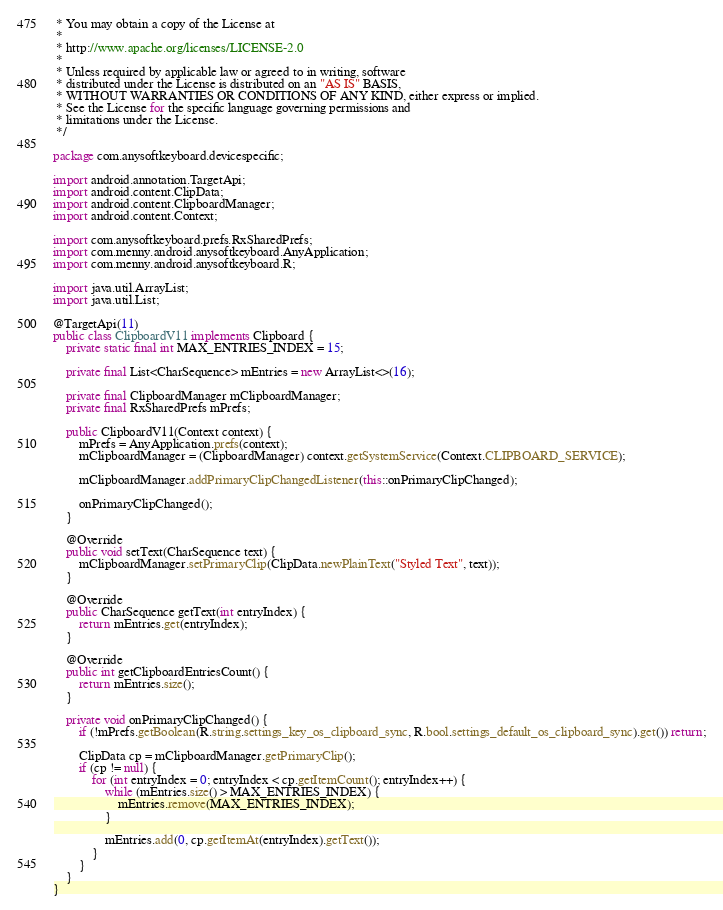Convert code to text. <code><loc_0><loc_0><loc_500><loc_500><_Java_> * You may obtain a copy of the License at
 *
 * http://www.apache.org/licenses/LICENSE-2.0
 *
 * Unless required by applicable law or agreed to in writing, software
 * distributed under the License is distributed on an "AS IS" BASIS,
 * WITHOUT WARRANTIES OR CONDITIONS OF ANY KIND, either express or implied.
 * See the License for the specific language governing permissions and
 * limitations under the License.
 */

package com.anysoftkeyboard.devicespecific;

import android.annotation.TargetApi;
import android.content.ClipData;
import android.content.ClipboardManager;
import android.content.Context;

import com.anysoftkeyboard.prefs.RxSharedPrefs;
import com.menny.android.anysoftkeyboard.AnyApplication;
import com.menny.android.anysoftkeyboard.R;

import java.util.ArrayList;
import java.util.List;

@TargetApi(11)
public class ClipboardV11 implements Clipboard {
    private static final int MAX_ENTRIES_INDEX = 15;

    private final List<CharSequence> mEntries = new ArrayList<>(16);

    private final ClipboardManager mClipboardManager;
    private final RxSharedPrefs mPrefs;

    public ClipboardV11(Context context) {
        mPrefs = AnyApplication.prefs(context);
        mClipboardManager = (ClipboardManager) context.getSystemService(Context.CLIPBOARD_SERVICE);

        mClipboardManager.addPrimaryClipChangedListener(this::onPrimaryClipChanged);

        onPrimaryClipChanged();
    }

    @Override
    public void setText(CharSequence text) {
        mClipboardManager.setPrimaryClip(ClipData.newPlainText("Styled Text", text));
    }

    @Override
    public CharSequence getText(int entryIndex) {
        return mEntries.get(entryIndex);
    }

    @Override
    public int getClipboardEntriesCount() {
        return mEntries.size();
    }

    private void onPrimaryClipChanged() {
        if (!mPrefs.getBoolean(R.string.settings_key_os_clipboard_sync, R.bool.settings_default_os_clipboard_sync).get()) return;

        ClipData cp = mClipboardManager.getPrimaryClip();
        if (cp != null) {
            for (int entryIndex = 0; entryIndex < cp.getItemCount(); entryIndex++) {
                while (mEntries.size() > MAX_ENTRIES_INDEX) {
                    mEntries.remove(MAX_ENTRIES_INDEX);
                }

                mEntries.add(0, cp.getItemAt(entryIndex).getText());
            }
        }
    }
}</code> 